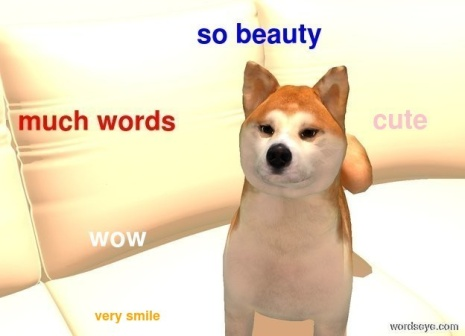Can you tell me more about the Shiba Inu's expression? The Shiba Inu's expression is quite charming. With its eyes gleaming and a slight smile playing across its lips, the dog exudes a sense of curiosity and playfulness. The relaxed positioning of the ears and the direct gaze towards the camera suggest a comfortable and content mood. This expression, combined with the humorous floating words around it, creates an endearing and amusing scene that is sure to bring a smile to any viewer's face. 